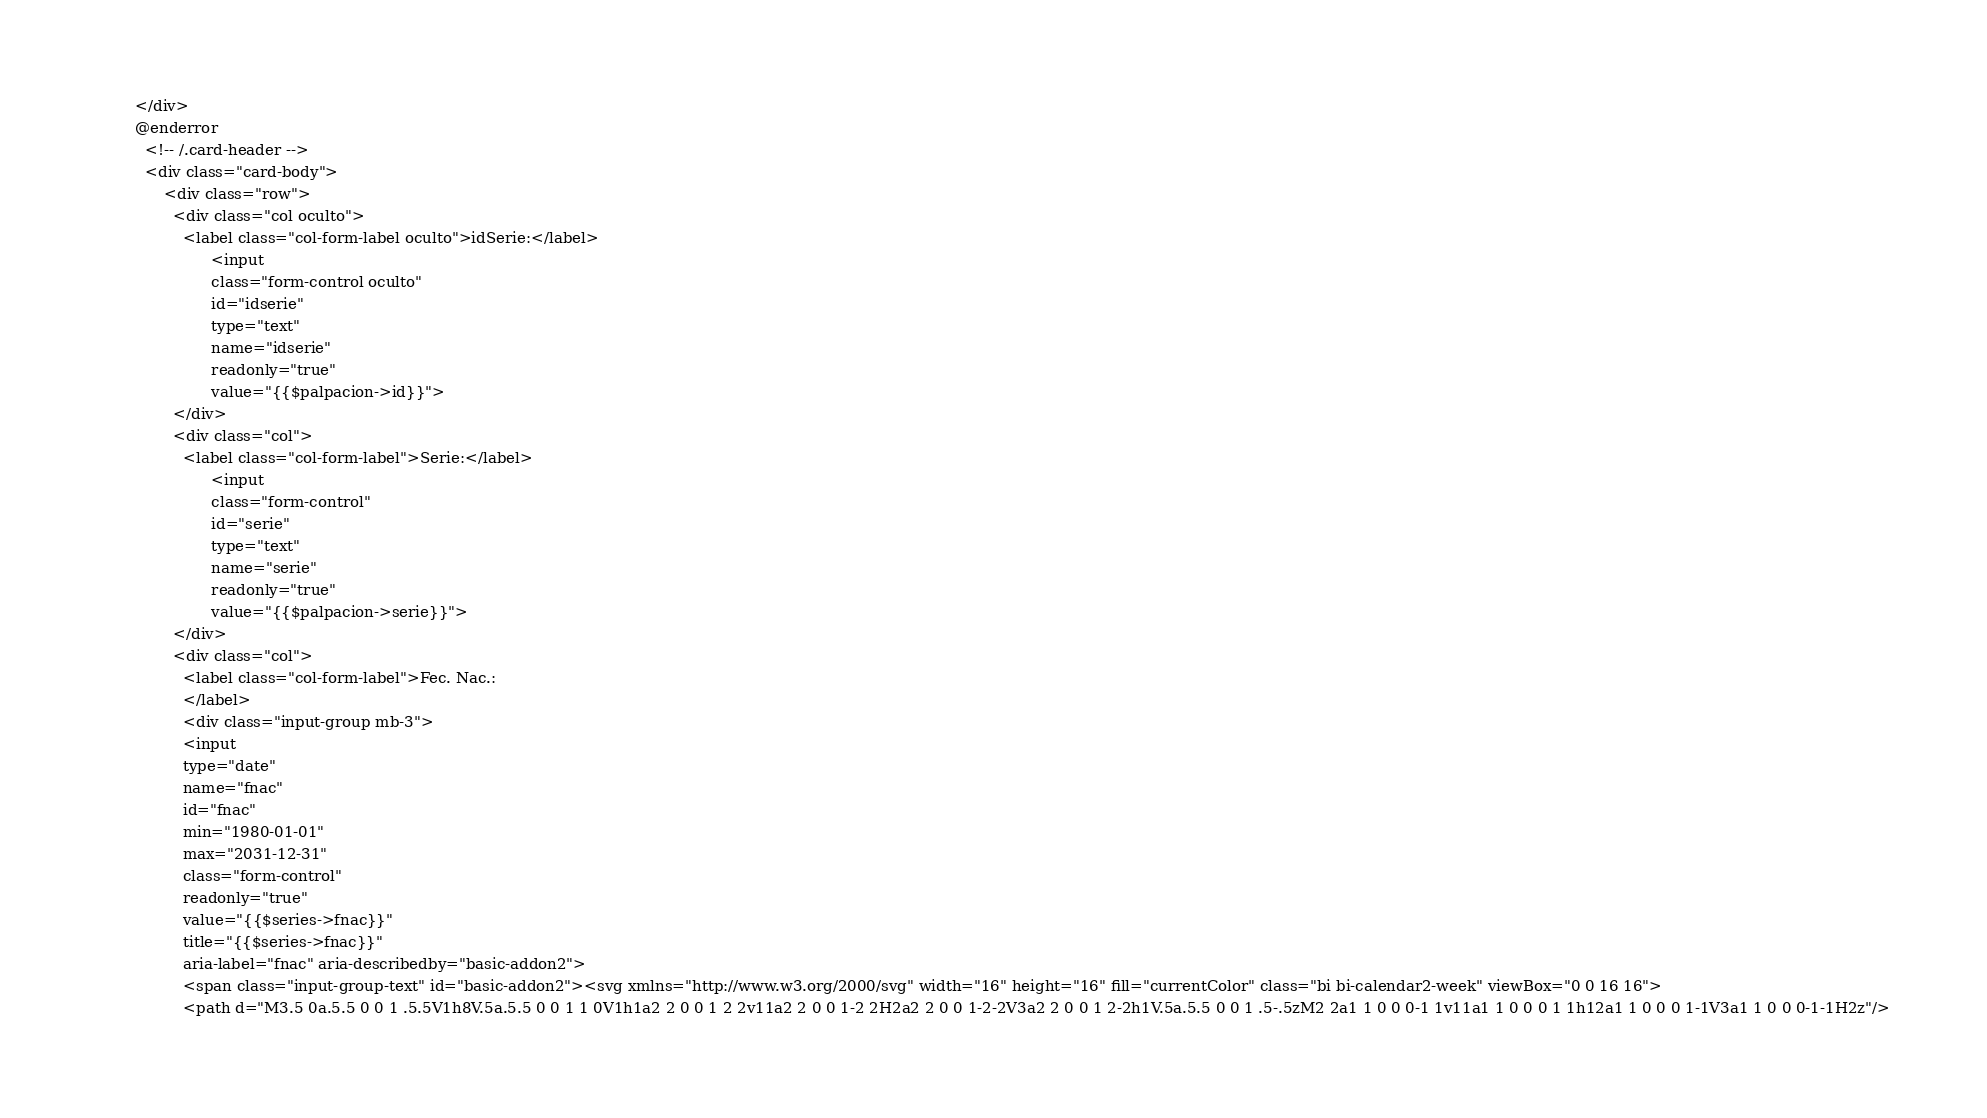Convert code to text. <code><loc_0><loc_0><loc_500><loc_500><_PHP_>        </div>
        @enderror
          <!-- /.card-header -->
          <div class="card-body">
              <div class="row">
                <div class="col oculto">
                  <label class="col-form-label oculto">idSerie:</label>
                        <input 
                        class="form-control oculto" 
                        id="idserie" 
                        type="text" 
                        name="idserie"
                        readonly="true" 
                        value="{{$palpacion->id}}">   
                </div>
                <div class="col">
                  <label class="col-form-label">Serie:</label>
                        <input 
                        class="form-control" 
                        id="serie" 
                        type="text" 
                        name="serie"
                        readonly="true" 
                        value="{{$palpacion->serie}}">   
                </div>
                <div class="col">
                  <label class="col-form-label">Fec. Nac.:
                  </label>
                  <div class="input-group mb-3">
                  <input 
                  type="date" 
                  name="fnac"
                  id="fnac"
                  min="1980-01-01" 
                  max="2031-12-31"
                  class="form-control" 
                  readonly="true"
                  value="{{$series->fnac}}"
                  title="{{$series->fnac}}"
                  aria-label="fnac" aria-describedby="basic-addon2">
                  <span class="input-group-text" id="basic-addon2"><svg xmlns="http://www.w3.org/2000/svg" width="16" height="16" fill="currentColor" class="bi bi-calendar2-week" viewBox="0 0 16 16">
                  <path d="M3.5 0a.5.5 0 0 1 .5.5V1h8V.5a.5.5 0 0 1 1 0V1h1a2 2 0 0 1 2 2v11a2 2 0 0 1-2 2H2a2 2 0 0 1-2-2V3a2 2 0 0 1 2-2h1V.5a.5.5 0 0 1 .5-.5zM2 2a1 1 0 0 0-1 1v11a1 1 0 0 0 1 1h12a1 1 0 0 0 1-1V3a1 1 0 0 0-1-1H2z"/></code> 